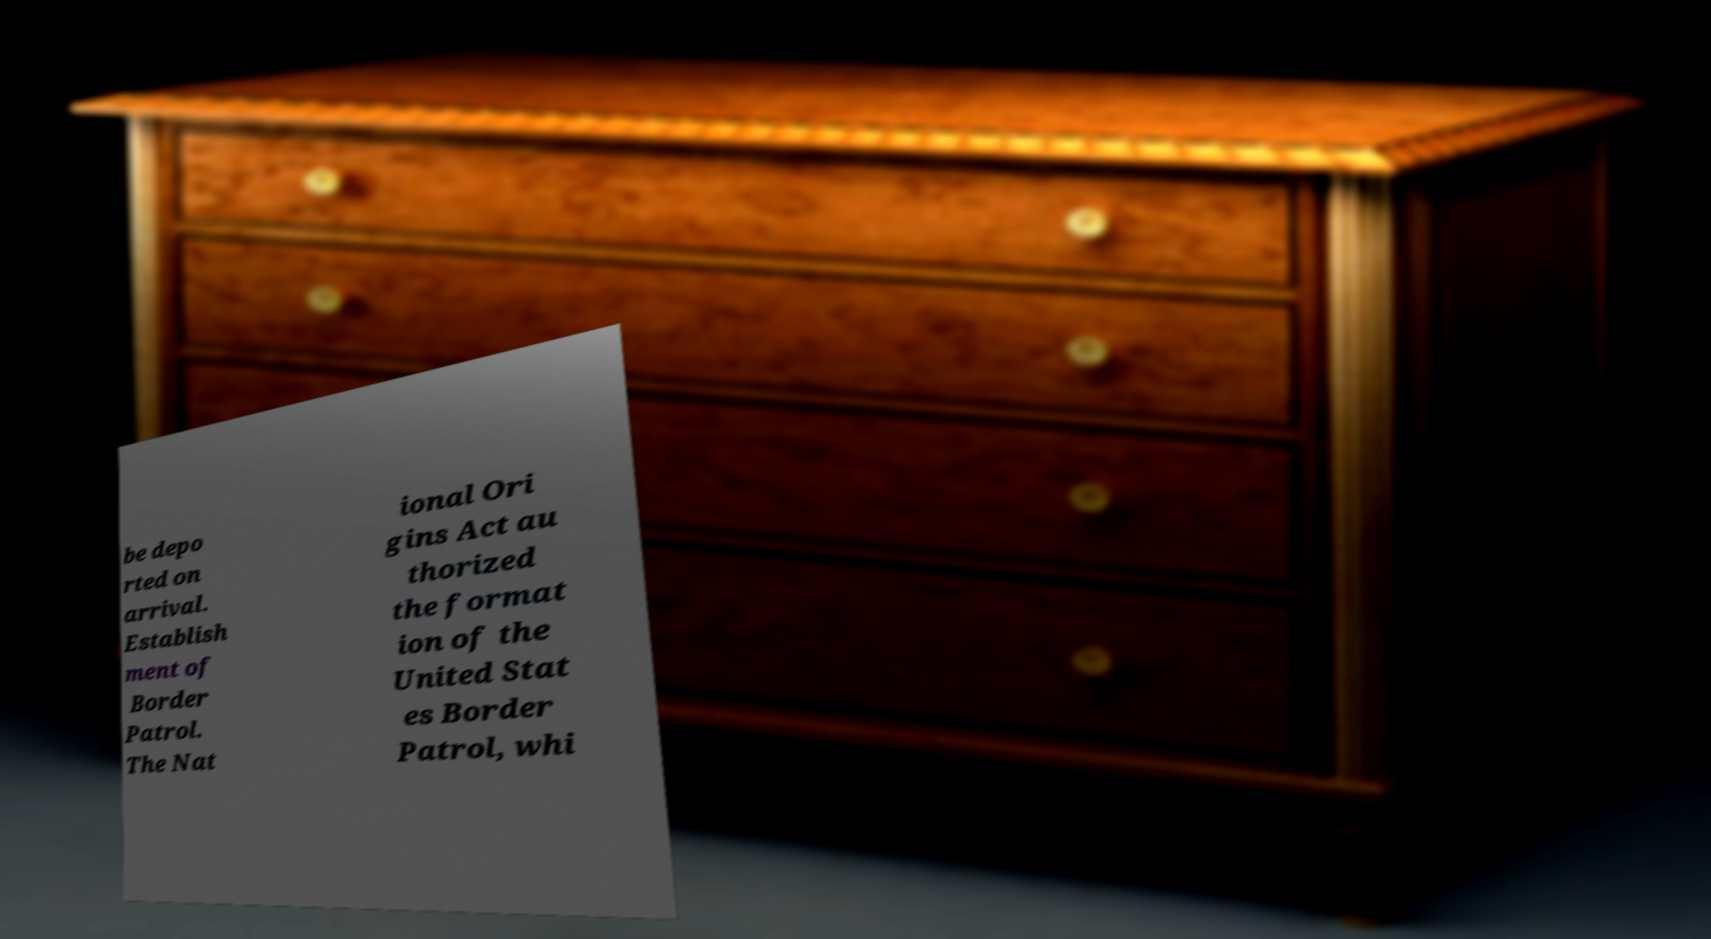What messages or text are displayed in this image? I need them in a readable, typed format. be depo rted on arrival. Establish ment of Border Patrol. The Nat ional Ori gins Act au thorized the format ion of the United Stat es Border Patrol, whi 